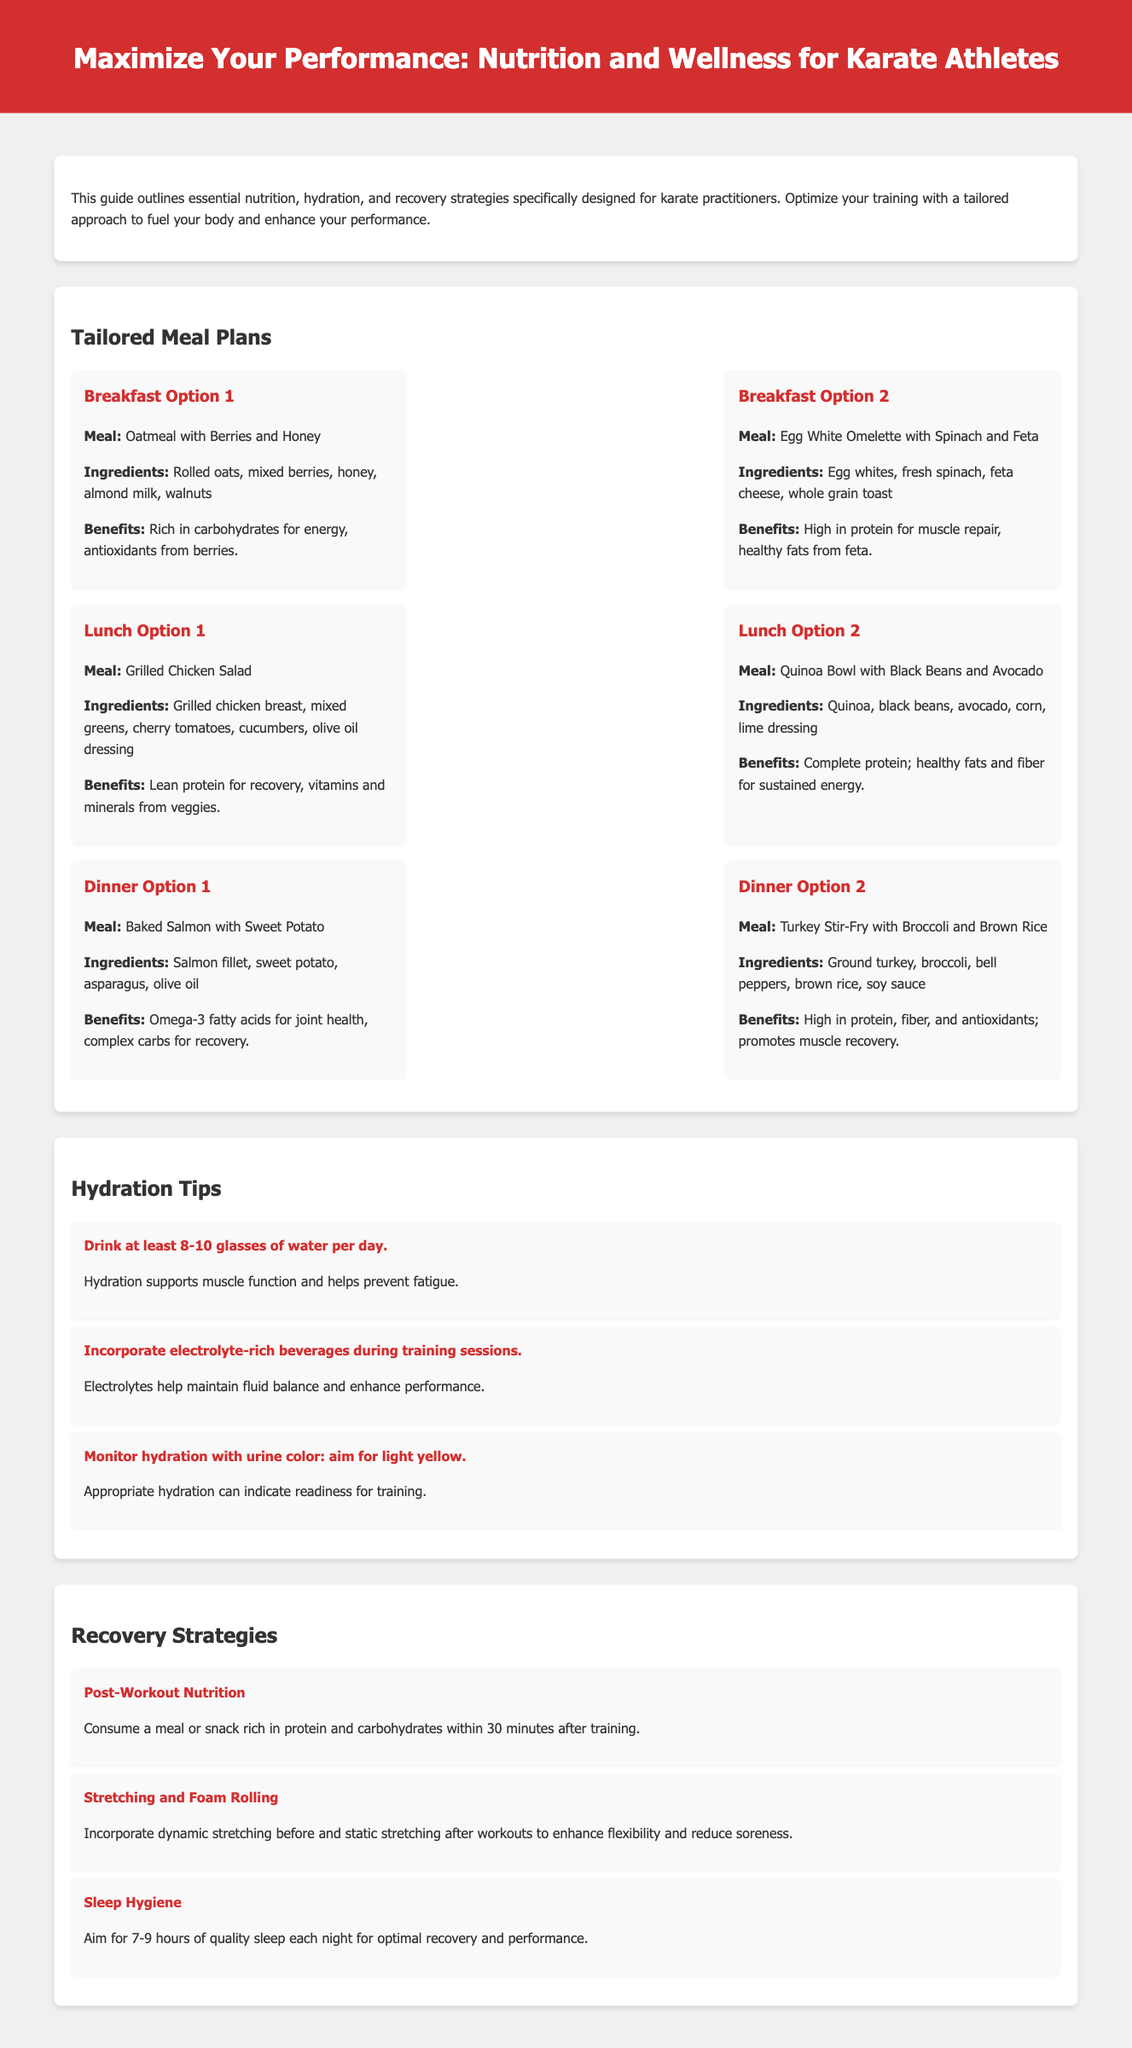what is the title of the document? The title is located at the top of the document in the header section.
Answer: Maximize Your Performance: Nutrition and Wellness for Karate Athletes how many breakfast options are provided? The document lists multiple breakfast options under the Tailored Meal Plans section.
Answer: 2 what are the ingredients in the first lunch option? The ingredients can be found in the Lunch Option 1 description.
Answer: Grilled chicken breast, mixed greens, cherry tomatoes, cucumbers, olive oil dressing what is the recommended water intake per day? This information is mentioned under the Hydration Tips section.
Answer: 8-10 glasses why is oatmeal with berries beneficial? The benefits are described alongside the meal options in the meal plan section.
Answer: Rich in carbohydrates for energy, antioxidants from berries what is one of the post-workout nutrition recommendations? This information is provided in the Recovery Strategies section for optimizing performance.
Answer: Consume a meal or snack rich in protein and carbohydrates within 30 minutes after training how many hours of sleep are recommended for optimal performance? This detail is found in the Recovery Strategies section.
Answer: 7-9 hours which meal includes Omega-3 fatty acids? This meal is mentioned in the Dinner Option 1 description.
Answer: Baked Salmon with Sweet Potato 